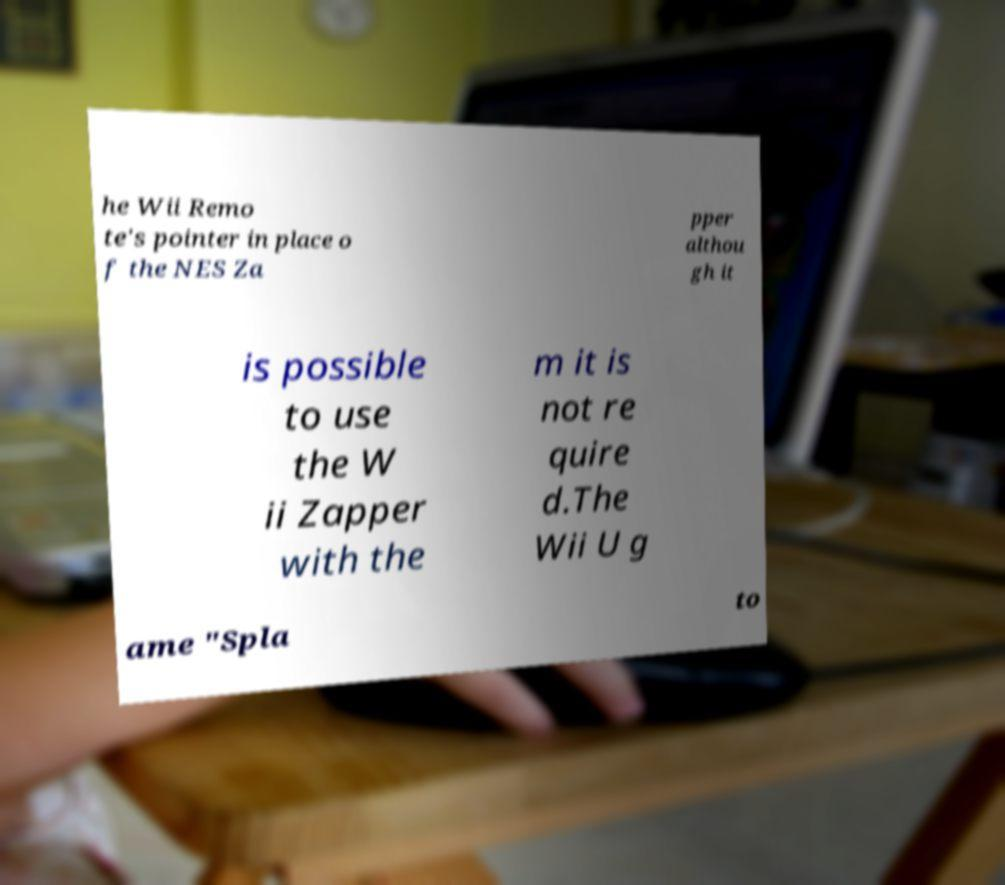Please read and relay the text visible in this image. What does it say? he Wii Remo te's pointer in place o f the NES Za pper althou gh it is possible to use the W ii Zapper with the m it is not re quire d.The Wii U g ame "Spla to 